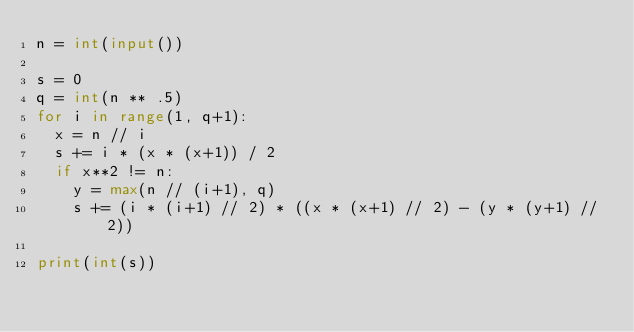Convert code to text. <code><loc_0><loc_0><loc_500><loc_500><_Python_>n = int(input())

s = 0
q = int(n ** .5)
for i in range(1, q+1):
	x = n // i
	s += i * (x * (x+1)) / 2
	if x**2 != n:
		y = max(n // (i+1), q)
		s += (i * (i+1) // 2) * ((x * (x+1) // 2) - (y * (y+1) // 2))

print(int(s))</code> 